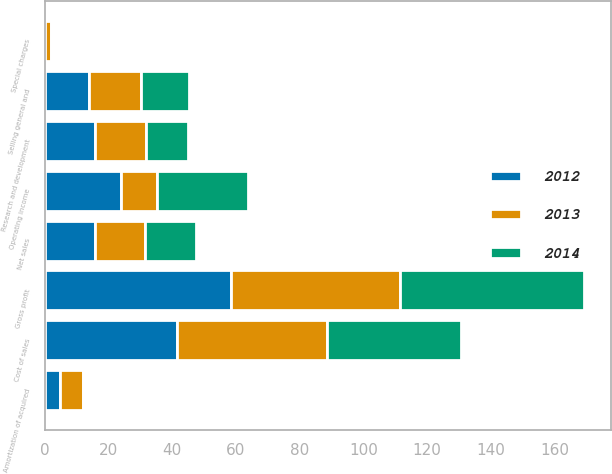Convert chart. <chart><loc_0><loc_0><loc_500><loc_500><stacked_bar_chart><ecel><fcel>Net sales<fcel>Cost of sales<fcel>Gross profit<fcel>Research and development<fcel>Selling general and<fcel>Amortization of acquired<fcel>Special charges<fcel>Operating income<nl><fcel>2012<fcel>15.8<fcel>41.6<fcel>58.4<fcel>15.8<fcel>13.8<fcel>4.9<fcel>0.1<fcel>23.8<nl><fcel>2013<fcel>15.8<fcel>47<fcel>53<fcel>16.1<fcel>16.5<fcel>7.1<fcel>2<fcel>11.3<nl><fcel>2014<fcel>15.8<fcel>42.2<fcel>57.8<fcel>13.2<fcel>15<fcel>0.8<fcel>0.1<fcel>28.7<nl></chart> 